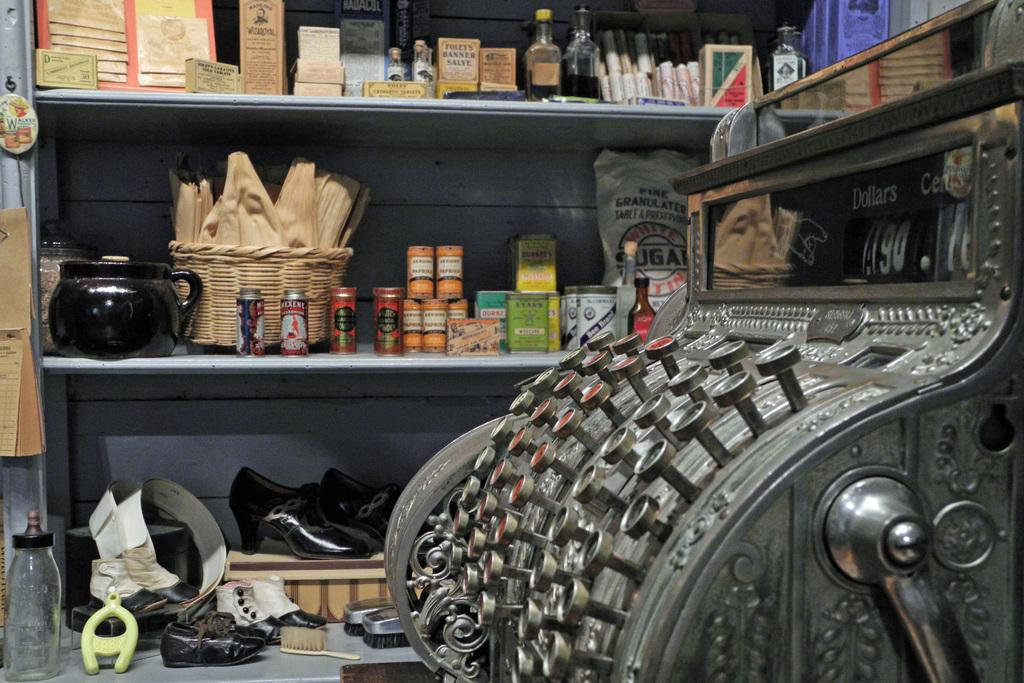What is the main object in the image? There is a machine in the image. What else can be seen in the image besides the machine? There are racks, sandals, shoes, boots, brushes, bottles, and a basket in the image. What type of footwear is present in the image? There are sandals, shoes, and boots in the image. What items might be used for cleaning or organizing in the image? Brushes and racks might be used for cleaning or organizing in the image. What type of dime can be seen in the image? There is no dime present in the image. What is the color of the copper in the image? There is no copper present in the image. 